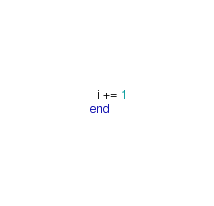Convert code to text. <code><loc_0><loc_0><loc_500><loc_500><_Crystal_>
  i += 1
end
</code> 